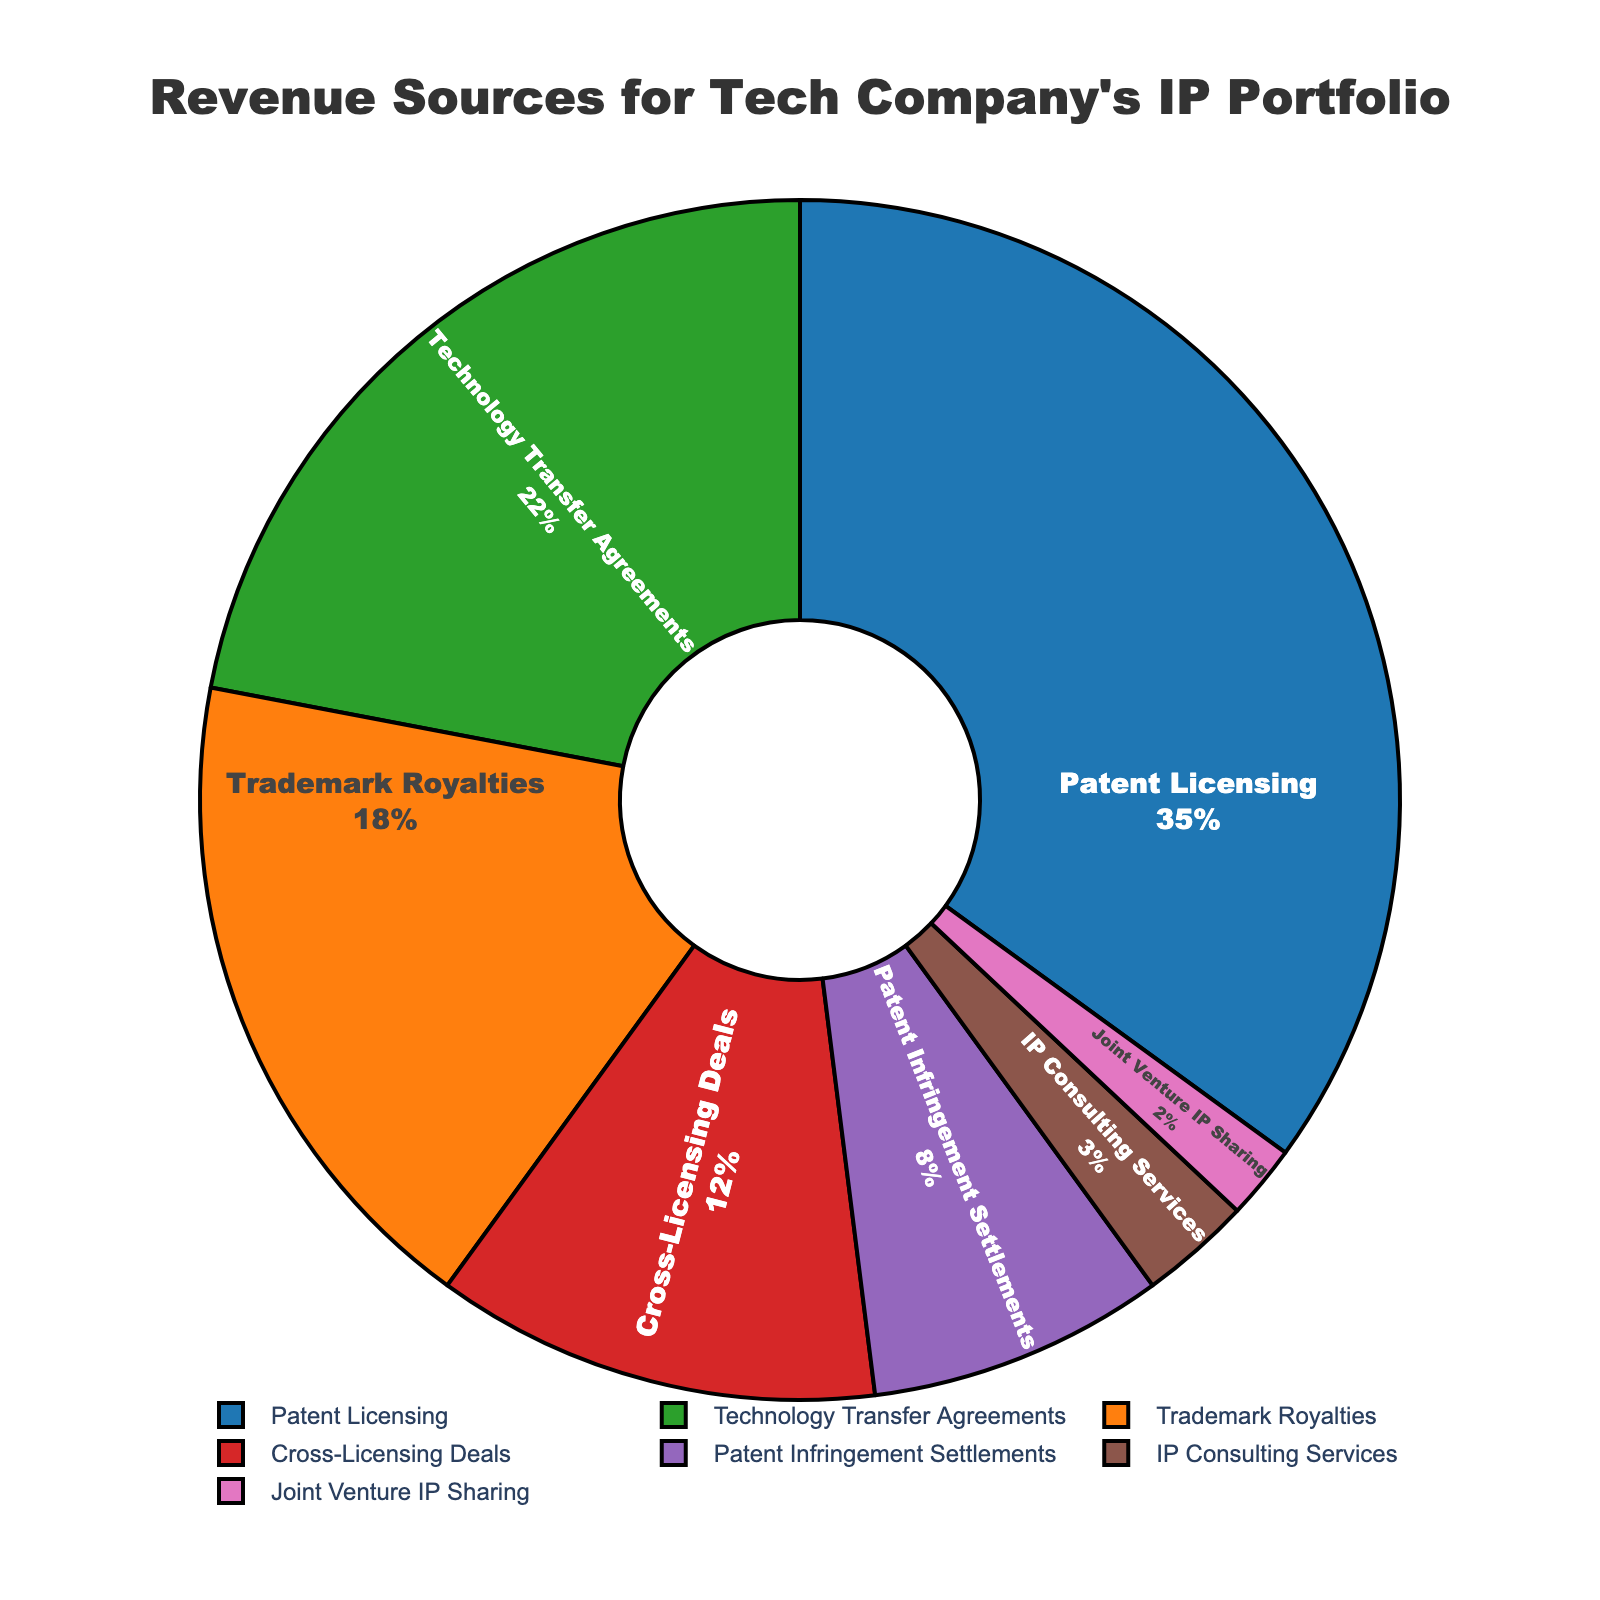What is the largest revenue source for the tech company's IP portfolio? The largest revenue source can be identified by looking for the slice that represents the highest percentage in the pie chart. Patent Licensing has the largest share, which is indicated as 35%.
Answer: Patent Licensing Which two revenue sources combined contribute to more than half of the total revenue? To determine if the combined percentages exceed 50%, sum the percentages of the sources. Patent Licensing (35%) + Technology Transfer Agreements (22%) = 57%, which is more than half.
Answer: Patent Licensing and Technology Transfer Agreements What percentage of the total revenue comes from sources other than Patent Licensing and Trademark Royalties? Sum the percentages of the other revenue sources: Technology Transfer Agreements (22%) + Cross-Licensing Deals (12%) + Patent Infringement Settlements (8%) + IP Consulting Services (3%) + Joint Venture IP Sharing (2%) = 47%.
Answer: 47% How does the revenue from Cross-Licensing Deals compare to that from Technology Transfer Agreements? Compare the two slices by examining the percentages. Cross-Licensing Deals account for 12%, while Technology Transfer Agreements account for 22%.
Answer: Cross-Licensing Deals are less than Technology Transfer Agreements What is the combined contribution from IP Consulting Services and Joint Venture IP Sharing? Add the percentages of these two revenue sources: IP Consulting Services (3%) + Joint Venture IP Sharing (2%) = 5%.
Answer: 5% Which revenue source has the second smallest contribution, and what is its percentage? Identify the second smallest slice following the smallest one (Joint Venture IP Sharing at 2%). The second smallest is IP Consulting Services at 3%.
Answer: IP Consulting Services, 3% Between Patent Infringement Settlements and Cross-Licensing Deals, which one contributes a higher percentage to the total revenue? Compare the two slices' percentages: Patent Infringement Settlements is 8%, and Cross-Licensing Deals is 12%.
Answer: Cross-Licensing Deals How much larger is the contribution from Patent Licensing compared to Patent Infringement Settlements? Subtract the percentage of Patent Infringement Settlements from that of Patent Licensing: 35% - 8% = 27%.
Answer: 27% What is the total percentage contribution of all the revenue sources that contribute less than 10% each? Sum the percentages of the sources with less than 10%: Patent Infringement Settlements (8%) + IP Consulting Services (3%) + Joint Venture IP Sharing (2%) = 13%.
Answer: 13% What is the average percentage contribution of all revenue sources? To find the average, sum all the percentages and divide by the number of sources: (35% + 18% + 22% + 12% + 8% + 3% + 2%) / 7 = 100% / 7 ≈ 14.29%.
Answer: ≈ 14.29% 